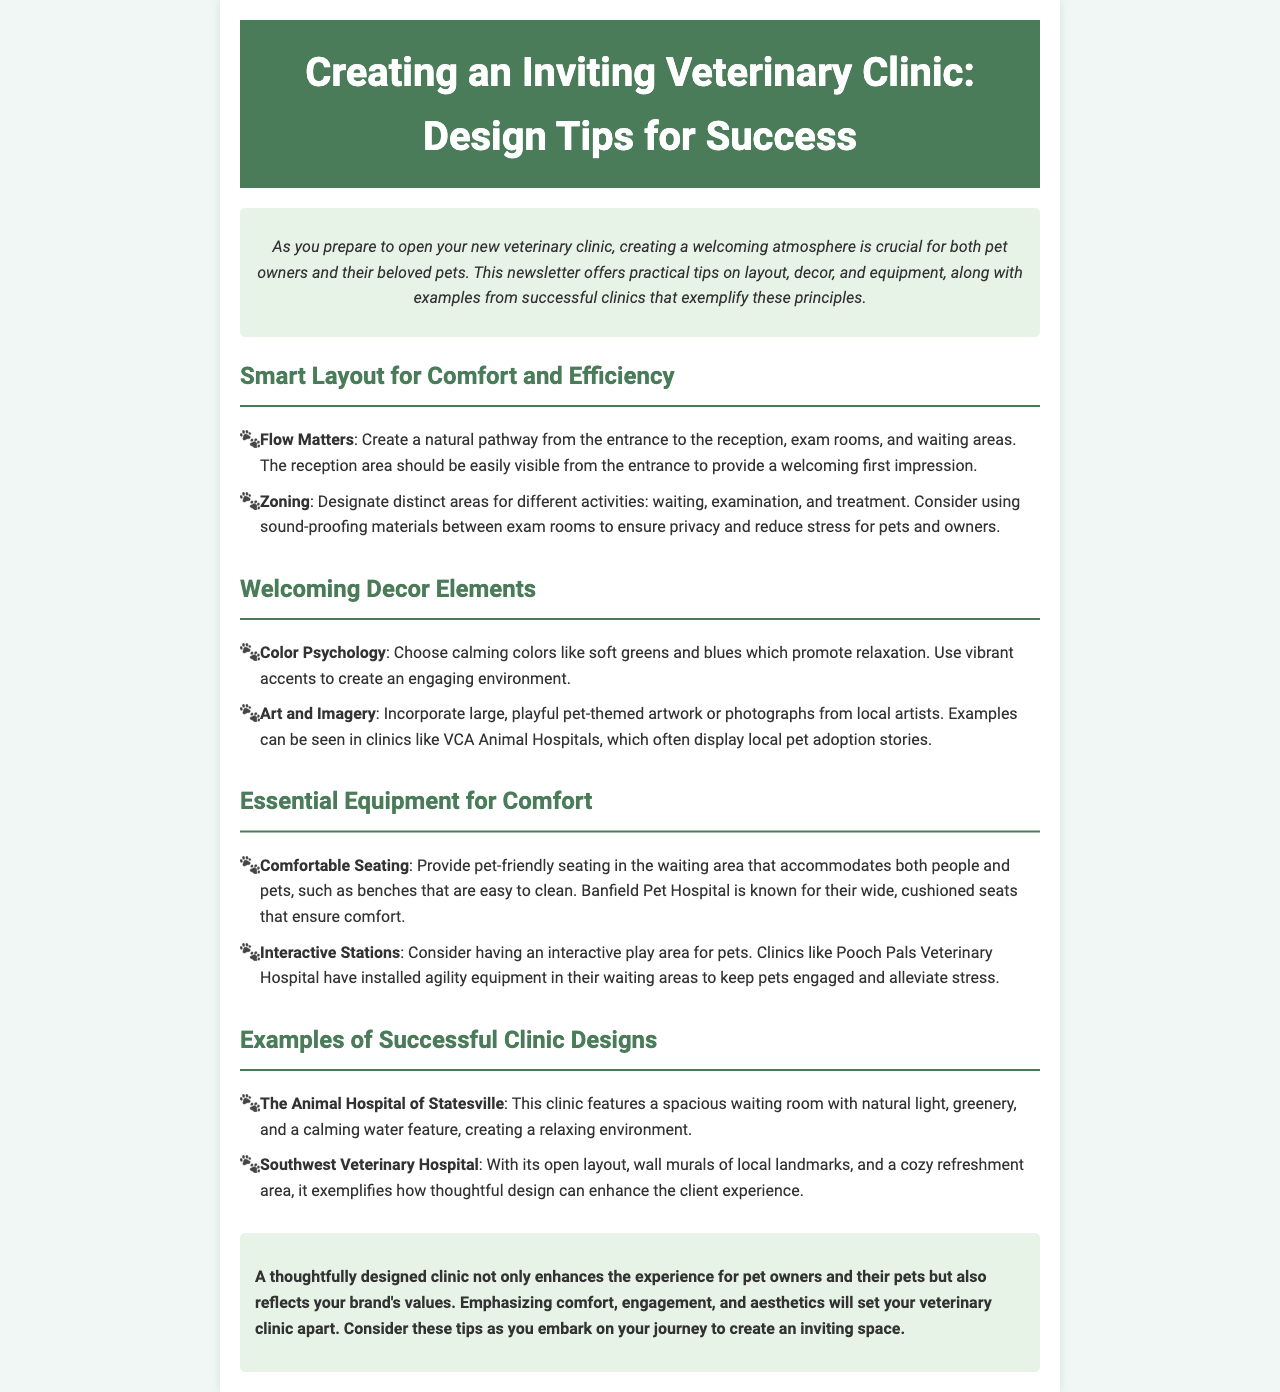what is the main focus of the newsletter? The newsletter focuses on tips for designing an inviting veterinary clinic space for pet owners and their pets.
Answer: tips for designing an inviting veterinary clinic space what should be the first visible area from the entrance? The reception area should be easily visible from the entrance to provide a welcoming first impression.
Answer: reception area which colors are recommended for a calming atmosphere? The newsletter suggests calming colors like soft greens and blues.
Answer: soft greens and blues what is a suggested feature in the waiting area? Clinics like Pooch Pals Veterinary Hospital have installed agility equipment in their waiting areas to keep pets engaged.
Answer: agility equipment which clinic is known for wide, cushioned seats? Banfield Pet Hospital is known for their wide, cushioned seats that ensure comfort.
Answer: Banfield Pet Hospital what design element enhances the client experience in the Southwest Veterinary Hospital? The open layout, wall murals of local landmarks, and a cozy refreshment area enhance the client experience.
Answer: open layout, wall murals, and cozy refreshment area how does color psychology relate to clinic decor? The document discusses choosing calming colors to promote relaxation and using vibrant accents to create an engaging environment.
Answer: calming colors and vibrant accents what is a benefit of using sound-proofing materials between exam rooms? Sound-proofing materials between exam rooms ensure privacy and reduce stress for pets and owners.
Answer: ensure privacy and reduce stress 